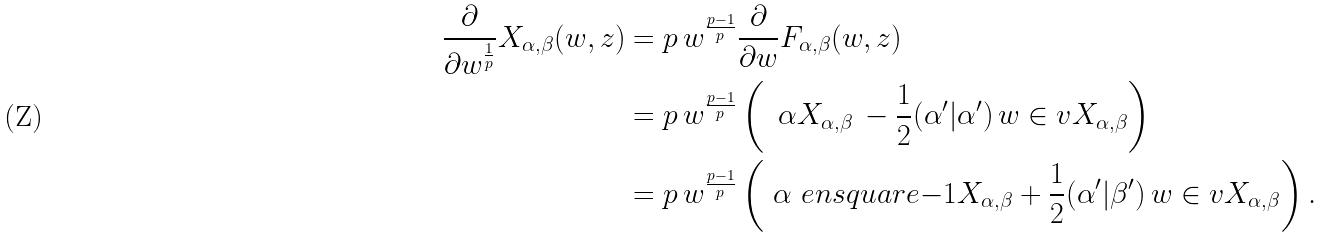<formula> <loc_0><loc_0><loc_500><loc_500>\frac { \partial } { \partial w ^ { \frac { 1 } { p } } } X _ { \alpha , \beta } ( w , z ) & = p \, w ^ { \frac { p - 1 } p } \frac { \partial } { \partial w } F _ { \alpha , \beta } ( w , z ) \\ & = p \, w ^ { \frac { p - 1 } p } \left ( \, \ \alpha X _ { \alpha , \beta } \, - \frac { 1 } { 2 } ( \alpha ^ { \prime } | \alpha ^ { \prime } ) \, w \in v X _ { \alpha , \beta } \right ) \\ & = p \, w ^ { \frac { p - 1 } p } \left ( \ \alpha \ e n s q u a r e { - 1 } X _ { \alpha , \beta } + \frac { 1 } { 2 } ( \alpha ^ { \prime } | \beta ^ { \prime } ) \, w \in v X _ { \alpha , \beta } \right ) .</formula> 